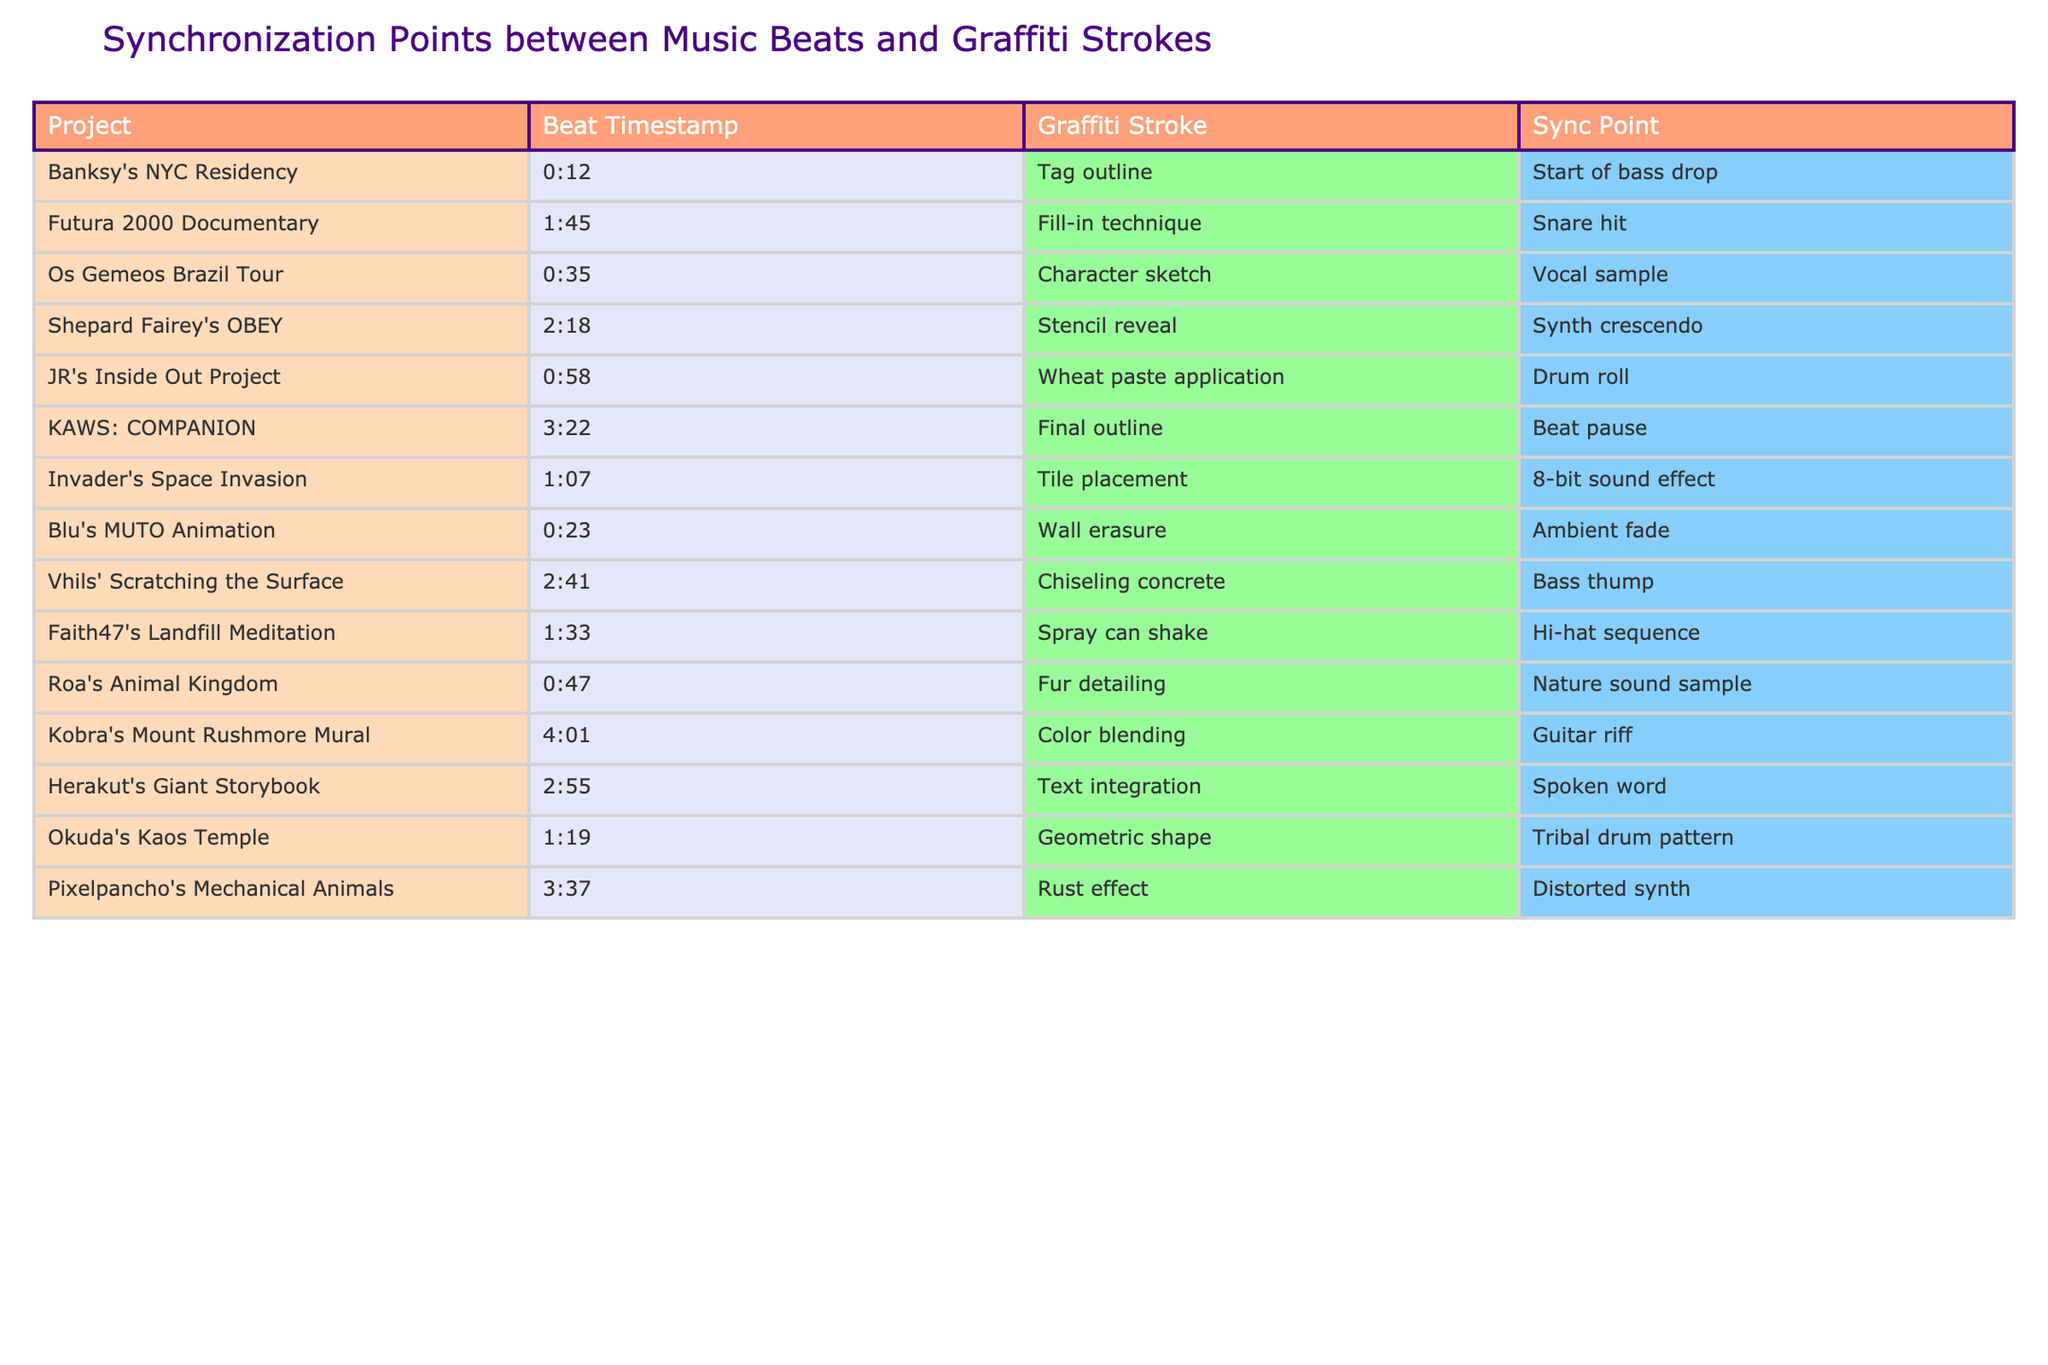What project has a synchronization point at the start of a bass drop? The table lists "Banksy's NYC Residency" with a beat timestamp of 0:12, which corresponds to the start of the bass drop for the "Tag outline" graffiti stroke.
Answer: Banksy's NYC Residency Which project features a sync point at a snare hit? By looking at the table, "Futura 2000 Documentary" has a graffiti stroke of "Fill-in technique" that is synchronized with a snare hit at 1:45.
Answer: Futura 2000 Documentary How many projects have synchronization points involving vocal samples? Scanning the entries for vocal samples, only "Os Gemeos Brazil Tour" at 0:35 has a vocal sample sync point paired with the character sketch stroke, indicating there’s just one project.
Answer: 1 What is the timestamp for the color blending technique in Kobra's mural? The table shows that the "Color blending" graffiti stroke in "Kobra's Mount Rushmore Mural" occurs at 4:01.
Answer: 4:01 Is there any project that has a sync point involving an 8-bit sound effect? The data indicates that "Invader's Space Invasion" features an 8-bit sound effect as the synchronization point for its tile placement stroke, thus the answer is yes.
Answer: Yes What is the average timestamp of synchronization points for the projects listed? The timestamps are: 0:12, 1:45, 0:35, 2:18, 0:58, 3:22, 1:07, 0:23, 2:41, 1:33, 0:47, 4:01, 2:55, 1:19, 3:37. Converting these into seconds, the averages are summed to a total of 4,027 seconds, divided by 15 projects gives approximately 268.5 seconds, which converts back to approximately 4:28 minutes.
Answer: 4:28 Which project has the longest timestamp among the given graffiti strokes? Looking through the timestamps, "Kobra's Mount Rushmore Mural" at 4:01 is the latest entry, confirming it as the longest timestamp in the list.
Answer: Kobra's Mount Rushmore Mural Are there any synchronizations with a spoken word segment? The table indicates that "Herakut's Giant Storybook" uses a spoken word for its sync point, confirming that at least one project employs this synchronization.
Answer: Yes What graffiti stroke synchronizes with a guitar riff? According to the table, "Kobra's Mount Rushmore Mural" uses "Color blending" as the graffiti stroke that syncs with a guitar riff.
Answer: Color blending How many different synchronization points are in the list? Each project has its unique synchronization point listed, resulting in 15 unique points across the data provided.
Answer: 15 Which is the only project that has a spray can shake at its synchronization point? The table specifies "Faith47's Landfill Meditation" has a spray can shake for its synchronization at 1:33 and does not list any other project with that stroke.
Answer: Faith47's Landfill Meditation 